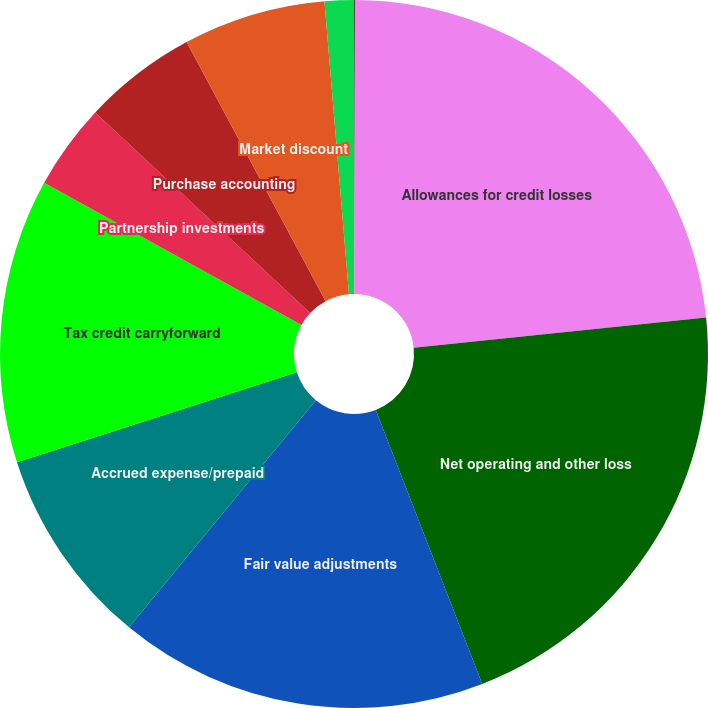Convert chart. <chart><loc_0><loc_0><loc_500><loc_500><pie_chart><fcel>(dollar amounts in thousands)<fcel>Allowances for credit losses<fcel>Net operating and other loss<fcel>Fair value adjustments<fcel>Accrued expense/prepaid<fcel>Tax credit carryforward<fcel>Partnership investments<fcel>Purchase accounting<fcel>Market discount<fcel>Other<nl><fcel>0.04%<fcel>23.32%<fcel>20.74%<fcel>16.86%<fcel>9.09%<fcel>12.98%<fcel>3.92%<fcel>5.21%<fcel>6.51%<fcel>1.33%<nl></chart> 